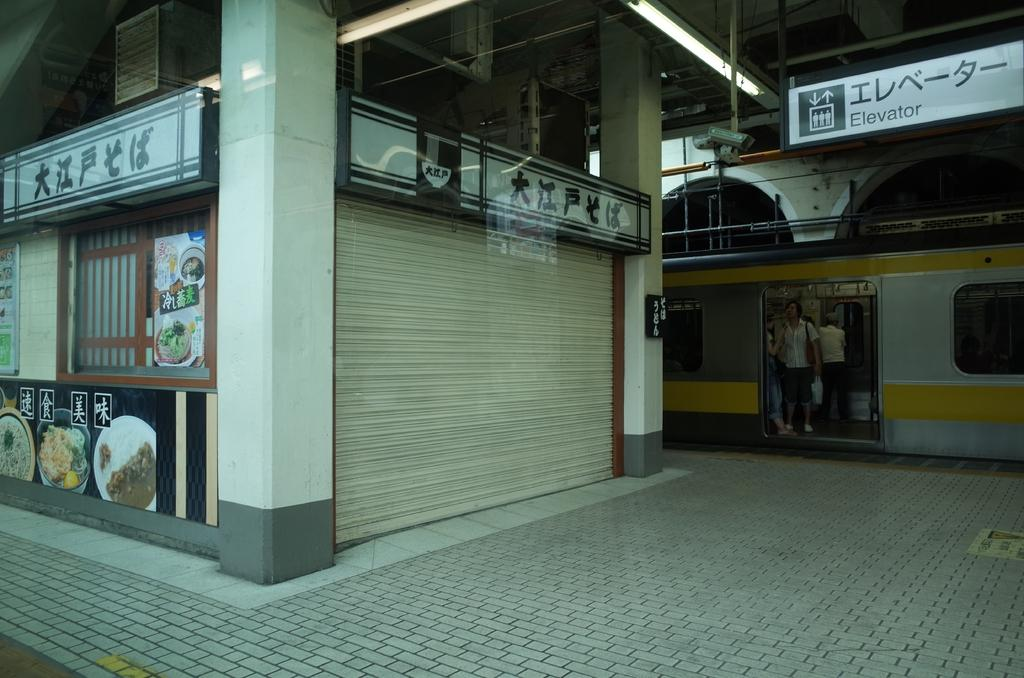What is the main subject of the image? The main subject of the image is a train. What can be seen inside the train? There are people standing in the train. What is present near the train? There is a hoarding in the image. What can be seen in the background of the image? There are lights visible in the image. What object is related to photography in the image? There is a shutter in the image. What type of basketball game is being played on the train in the image? There is no basketball game being played in the image; it features a train with people standing inside and a hoarding nearby. How many sheep can be seen grazing near the train in the image? There are no sheep present in the image; it only features a train, people, a hoarding, lights, and a shutter. 